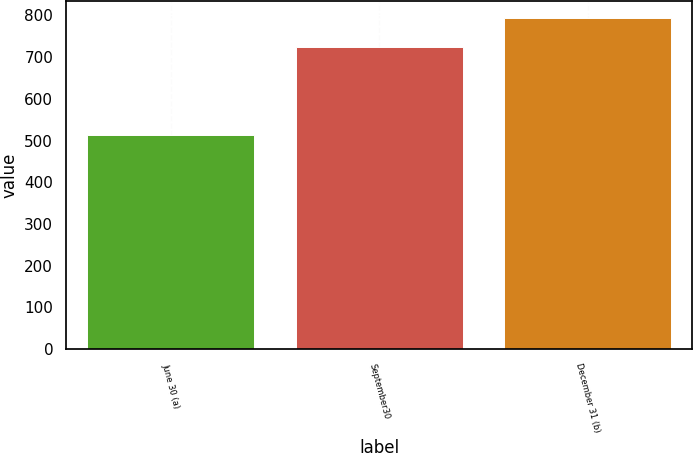<chart> <loc_0><loc_0><loc_500><loc_500><bar_chart><fcel>June 30 (a)<fcel>September30<fcel>December 31 (b)<nl><fcel>514<fcel>725<fcel>795<nl></chart> 